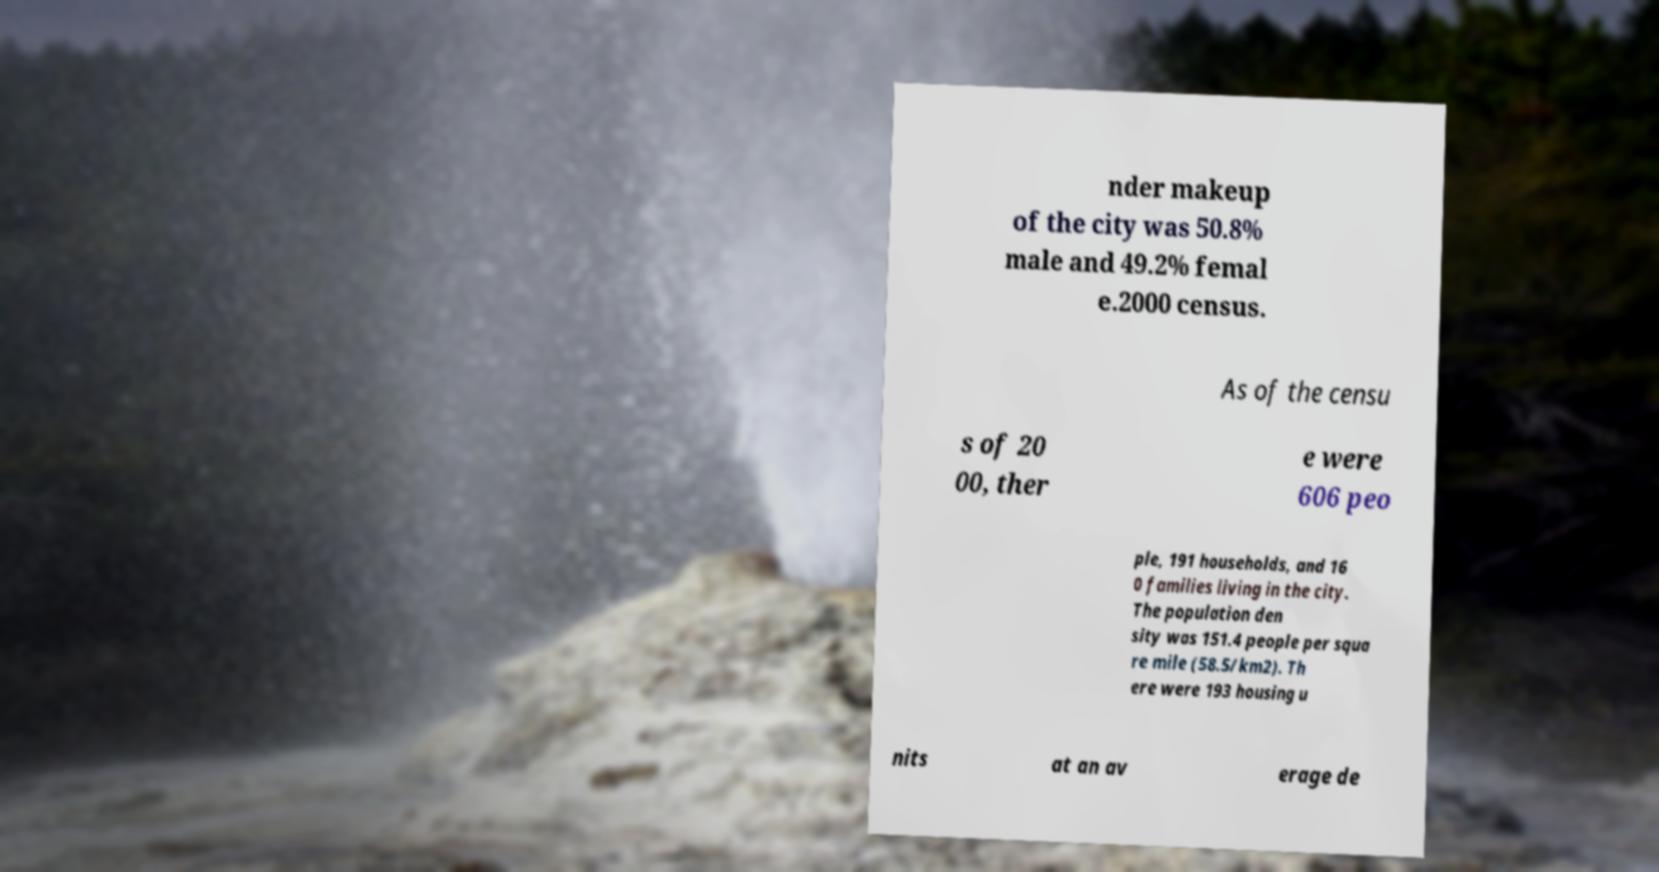Could you extract and type out the text from this image? nder makeup of the city was 50.8% male and 49.2% femal e.2000 census. As of the censu s of 20 00, ther e were 606 peo ple, 191 households, and 16 0 families living in the city. The population den sity was 151.4 people per squa re mile (58.5/km2). Th ere were 193 housing u nits at an av erage de 